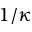Convert formula to latex. <formula><loc_0><loc_0><loc_500><loc_500>1 / \kappa</formula> 